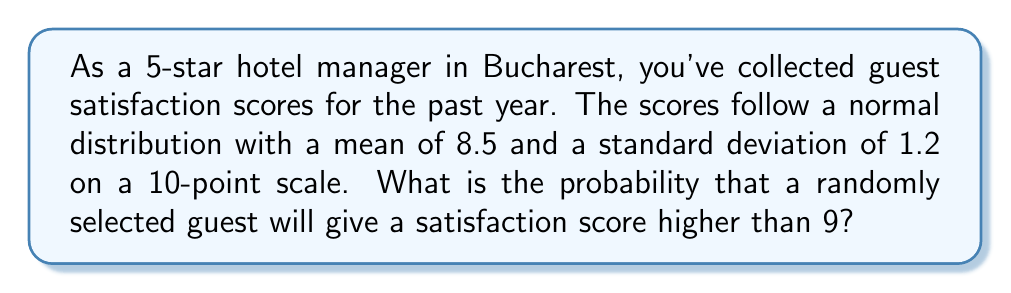Give your solution to this math problem. Let's approach this step-by-step:

1) We're dealing with a normal distribution where:
   Mean (μ) = 8.5
   Standard deviation (σ) = 1.2

2) We want to find P(X > 9), where X is the satisfaction score.

3) To solve this, we need to calculate the z-score for 9:

   $$z = \frac{x - μ}{σ} = \frac{9 - 8.5}{1.2} = \frac{0.5}{1.2} ≈ 0.4167$$

4) Now we need to find P(Z > 0.4167) where Z is the standard normal variable.

5) Using a standard normal table or calculator, we can find that:
   P(Z < 0.4167) ≈ 0.6616

6) Since we want the probability of being greater than 0.4167, we subtract this from 1:

   P(Z > 0.4167) = 1 - P(Z < 0.4167) = 1 - 0.6616 = 0.3384

7) Therefore, the probability of a randomly selected guest giving a satisfaction score higher than 9 is approximately 0.3384 or 33.84%.
Answer: 0.3384 